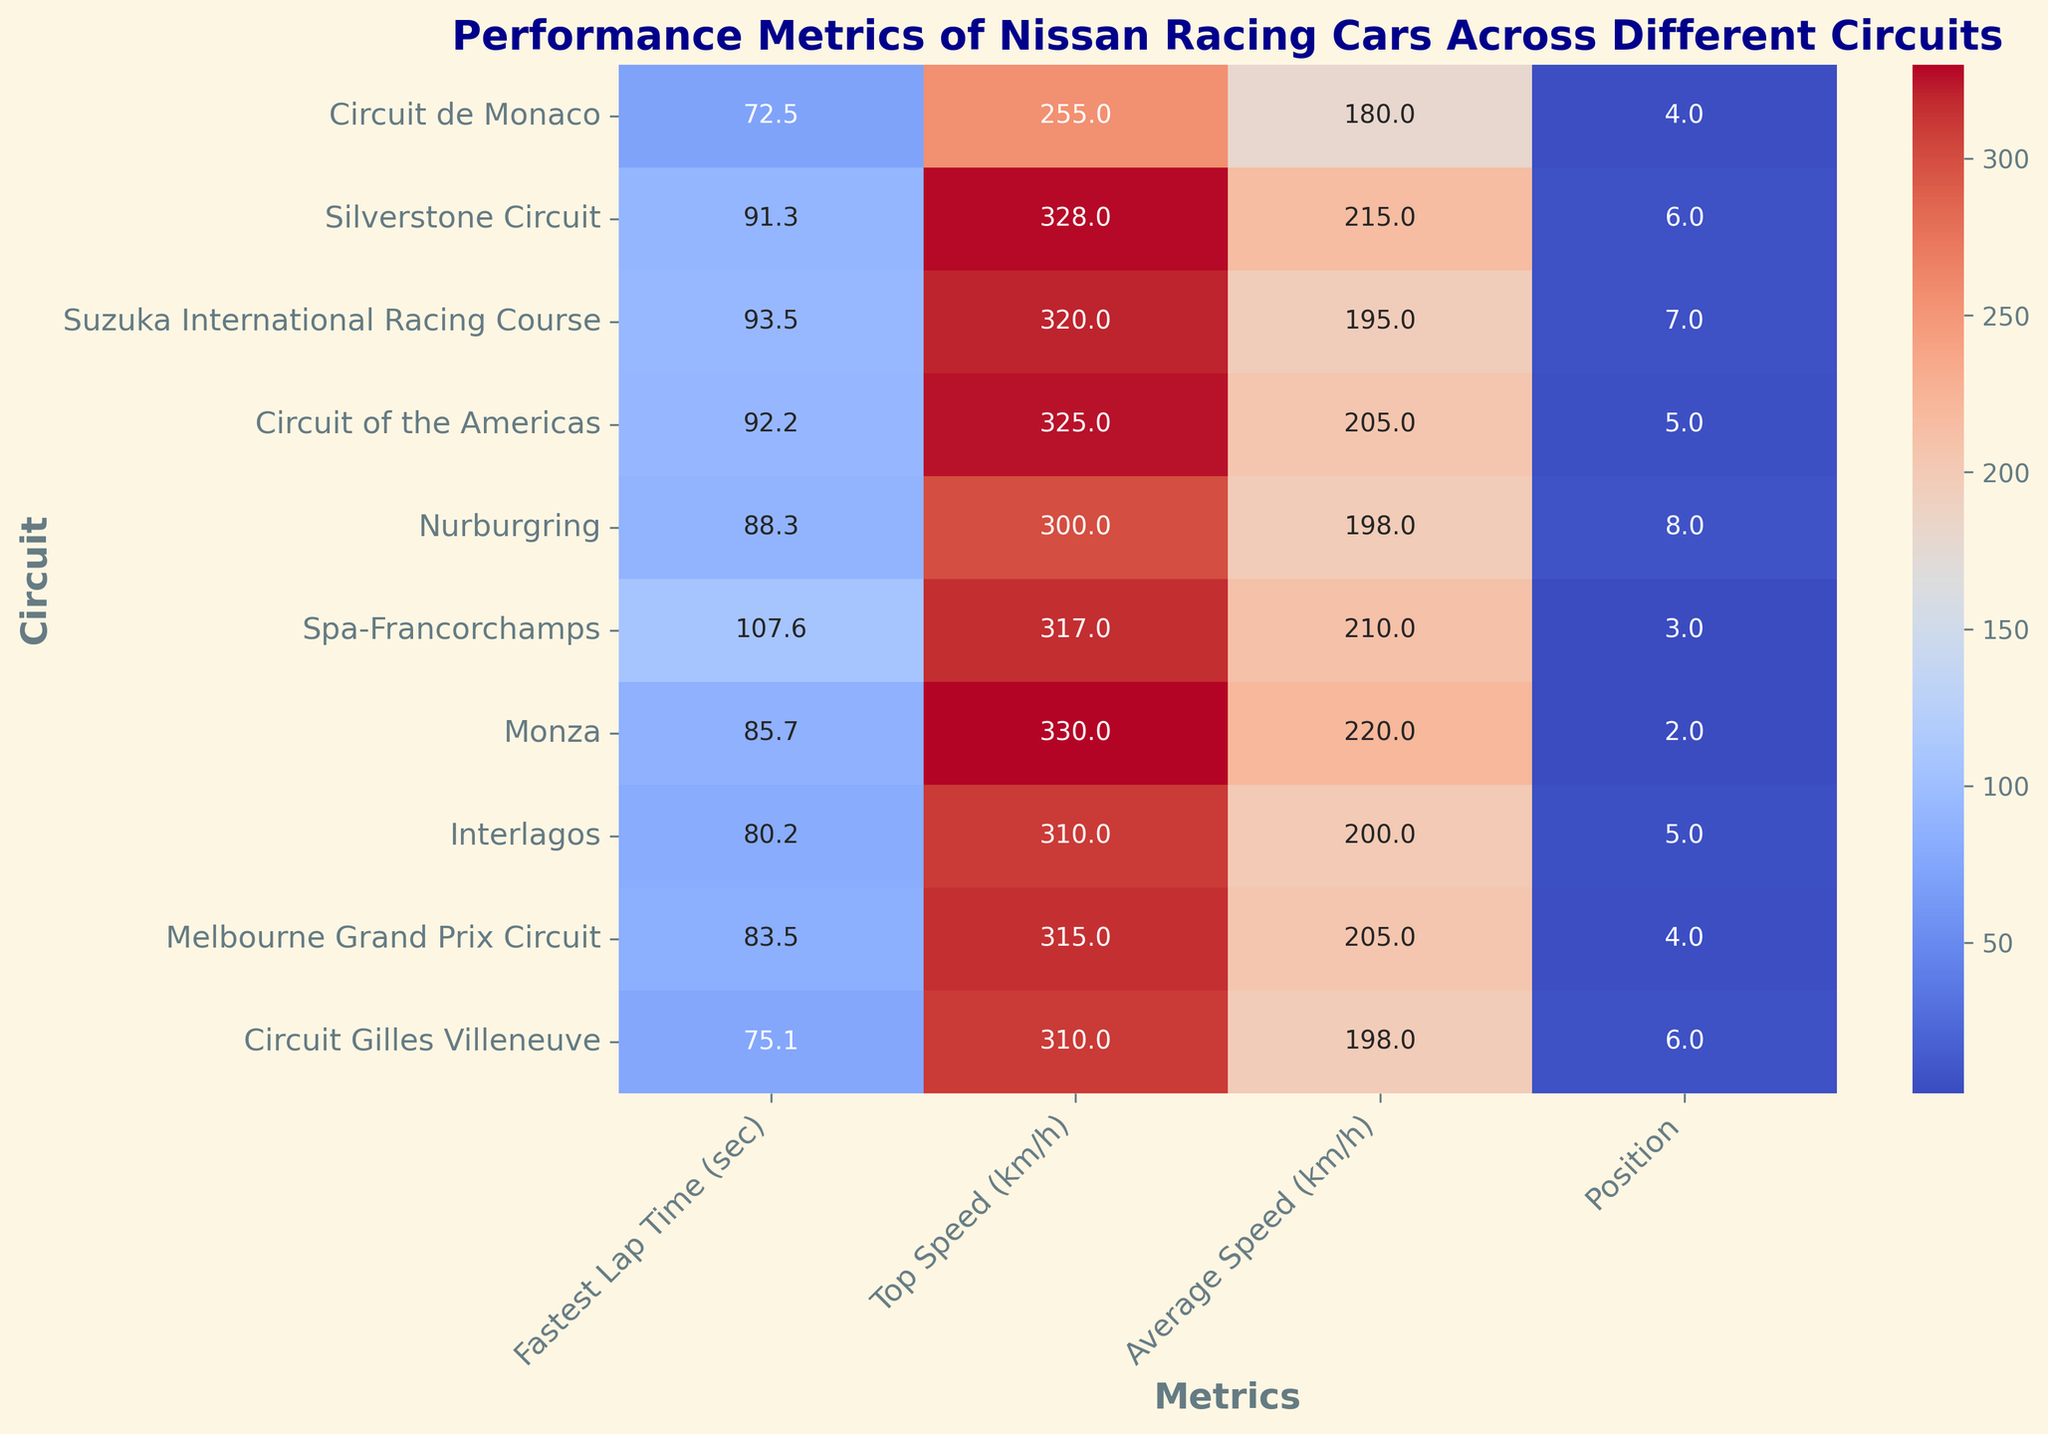Which circuit had the fastest lap time? Look for the smallest value in the "Fastest Lap Time (sec)" column and note the corresponding circuit.
Answer: Circuit de Monaco Which circuit had the highest top speed? Look for the largest value in the "Top Speed (km/h)" column and note the corresponding circuit.
Answer: Monza Which circuits had a better position than Circuit de Monaco? Find circuits with a position number lower than 4 (since lower is better) and list the corresponding circuits.
Answer: Spa-Francorchamps, Monza, Melbourne Grand Prix Circuit Which circuit had the lowest average speed? Look for the smallest value in the "Average Speed (km/h)" column and note the corresponding circuit.
Answer: Circuit de Monaco Which circuit had the smallest difference between top speed and average speed? Calculate the difference for each circuit and identify the minimum value.
Answer: Circuit de Monaco (255 - 180 = 75) Which metric shows the highest variance across circuits? Visually inspect the heatmap for the metric with the largest variability in colors.
Answer: Fastest Lap Time (sec) Which circuit's metrics are most consistently strong across all parameters? Look at the heatmap rows to find the circuit with high performance (more uniform, darker shades for speed and lighter shades for position) across all metrics.
Answer: Monza 